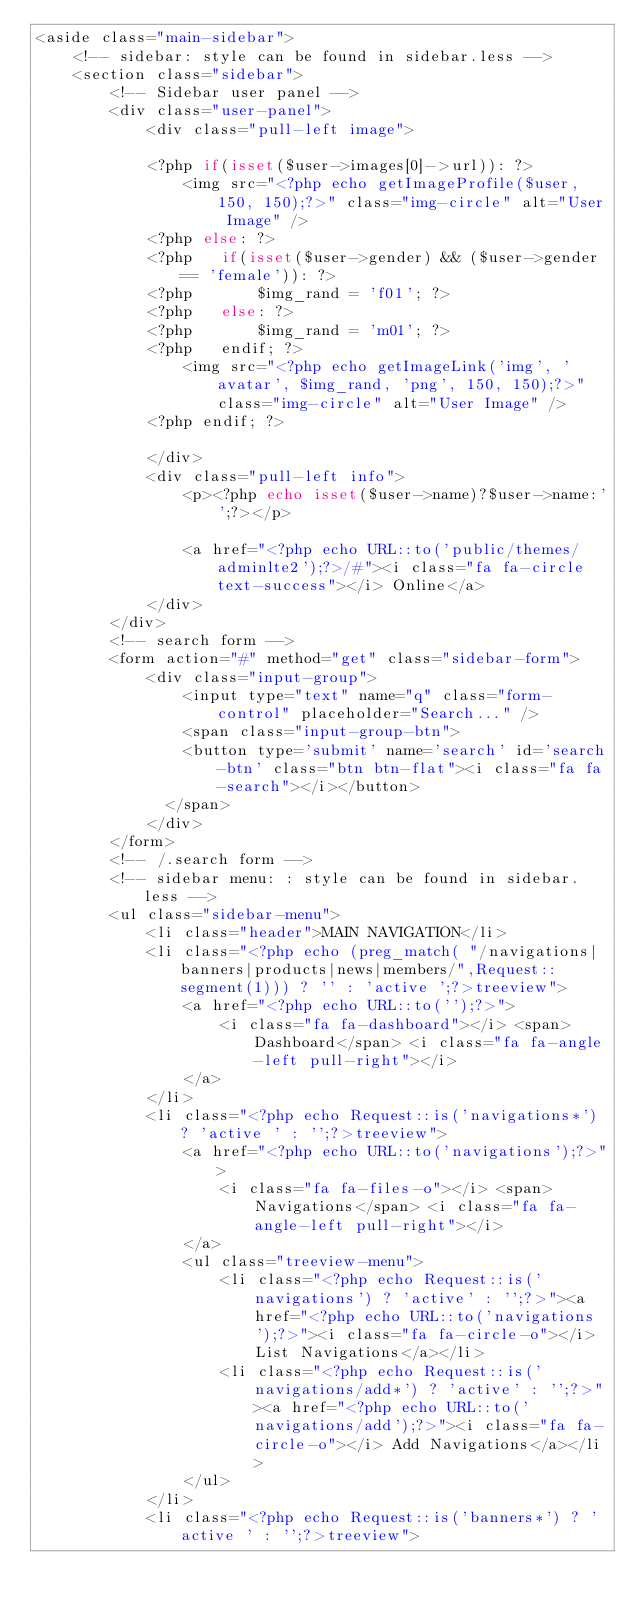Convert code to text. <code><loc_0><loc_0><loc_500><loc_500><_PHP_><aside class="main-sidebar">
    <!-- sidebar: style can be found in sidebar.less -->
    <section class="sidebar">
        <!-- Sidebar user panel -->
        <div class="user-panel">
            <div class="pull-left image">

            <?php if(isset($user->images[0]->url)): ?>
                <img src="<?php echo getImageProfile($user, 150, 150);?>" class="img-circle" alt="User Image" />
            <?php else: ?>
            <?php   if(isset($user->gender) && ($user->gender == 'female')): ?>
            <?php       $img_rand = 'f01'; ?>
            <?php   else: ?>
            <?php       $img_rand = 'm01'; ?>
            <?php   endif; ?>
                <img src="<?php echo getImageLink('img', 'avatar', $img_rand, 'png', 150, 150);?>" class="img-circle" alt="User Image" />
            <?php endif; ?>
                
            </div>
            <div class="pull-left info">
                <p><?php echo isset($user->name)?$user->name:'';?></p>

                <a href="<?php echo URL::to('public/themes/adminlte2');?>/#"><i class="fa fa-circle text-success"></i> Online</a>
            </div>
        </div>
        <!-- search form -->
        <form action="#" method="get" class="sidebar-form">
            <div class="input-group">
                <input type="text" name="q" class="form-control" placeholder="Search..." />
                <span class="input-group-btn">
                <button type='submit' name='search' id='search-btn' class="btn btn-flat"><i class="fa fa-search"></i></button>
              </span>
            </div>
        </form>
        <!-- /.search form -->
        <!-- sidebar menu: : style can be found in sidebar.less -->
        <ul class="sidebar-menu">
            <li class="header">MAIN NAVIGATION</li>
            <li class="<?php echo (preg_match( "/navigations|banners|products|news|members/",Request::segment(1))) ? '' : 'active ';?>treeview">
                <a href="<?php echo URL::to('');?>">
                    <i class="fa fa-dashboard"></i> <span>Dashboard</span> <i class="fa fa-angle-left pull-right"></i>
                </a>
            </li>
            <li class="<?php echo Request::is('navigations*') ? 'active ' : '';?>treeview">
                <a href="<?php echo URL::to('navigations');?>">
                    <i class="fa fa-files-o"></i> <span>Navigations</span> <i class="fa fa-angle-left pull-right"></i>
                </a>
                <ul class="treeview-menu">
                    <li class="<?php echo Request::is('navigations') ? 'active' : '';?>"><a href="<?php echo URL::to('navigations');?>"><i class="fa fa-circle-o"></i> List Navigations</a></li>
                    <li class="<?php echo Request::is('navigations/add*') ? 'active' : '';?>"><a href="<?php echo URL::to('navigations/add');?>"><i class="fa fa-circle-o"></i> Add Navigations</a></li>
                </ul>
            </li>
            <li class="<?php echo Request::is('banners*') ? 'active ' : '';?>treeview"></code> 